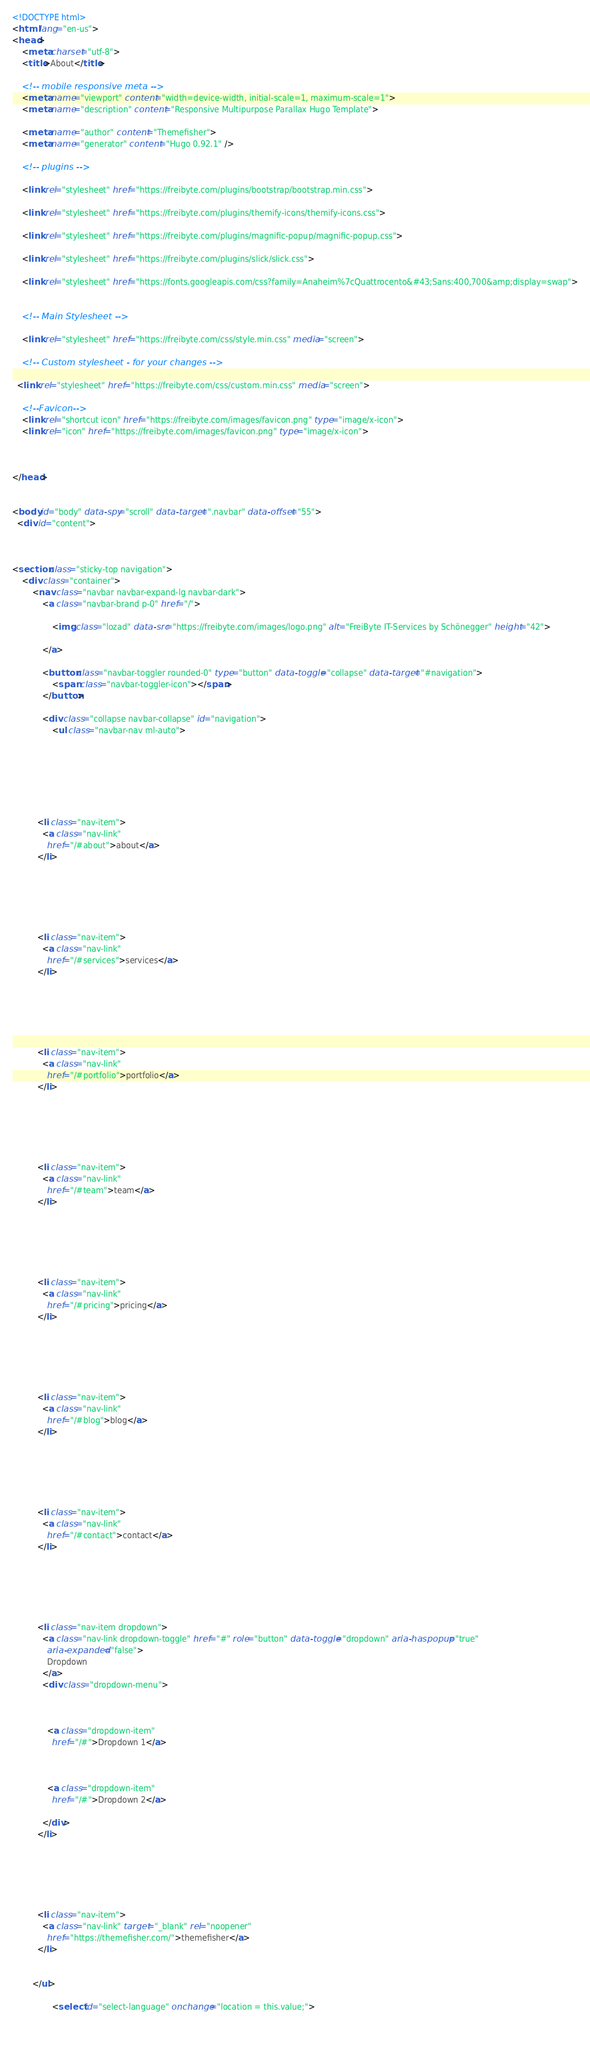Convert code to text. <code><loc_0><loc_0><loc_500><loc_500><_HTML_><!DOCTYPE html>
<html lang="en-us">
<head>
	<meta charset="utf-8">
	<title>About</title>

	<!-- mobile responsive meta -->
	<meta name="viewport" content="width=device-width, initial-scale=1, maximum-scale=1">
	<meta name="description" content="Responsive Multipurpose Parallax Hugo Template">
	
	<meta name="author" content="Themefisher">
	<meta name="generator" content="Hugo 0.92.1" />

	<!-- plugins -->
	
	<link rel="stylesheet" href="https://freibyte.com/plugins/bootstrap/bootstrap.min.css">
	
	<link rel="stylesheet" href="https://freibyte.com/plugins/themify-icons/themify-icons.css">
	
	<link rel="stylesheet" href="https://freibyte.com/plugins/magnific-popup/magnific-popup.css">
	
	<link rel="stylesheet" href="https://freibyte.com/plugins/slick/slick.css">
	
	<link rel="stylesheet" href="https://fonts.googleapis.com/css?family=Anaheim%7cQuattrocento&#43;Sans:400,700&amp;display=swap">
	

	<!-- Main Stylesheet -->
	
	<link rel="stylesheet" href="https://freibyte.com/css/style.min.css" media="screen">

	<!-- Custom stylesheet - for your changes -->
	
  <link rel="stylesheet" href="https://freibyte.com/css/custom.min.css" media="screen">

	<!--Favicon-->
	<link rel="shortcut icon" href="https://freibyte.com/images/favicon.png" type="image/x-icon">
	<link rel="icon" href="https://freibyte.com/images/favicon.png" type="image/x-icon">

	

</head>


<body id="body" data-spy="scroll" data-target=".navbar" data-offset="55">
  <div id="content">
    


<section class="sticky-top navigation">
	<div class="container">
		<nav class="navbar navbar-expand-lg navbar-dark">
			<a class="navbar-brand p-0" href="/">
				
				<img class="lozad" data-src="https://freibyte.com/images/logo.png" alt="FreiByte IT-Services by Schönegger" height="42">
				
			</a>

			<button class="navbar-toggler rounded-0" type="button" data-toggle="collapse" data-target="#navigation">
				<span class="navbar-toggler-icon"></span>
			</button>

			<div class="collapse navbar-collapse" id="navigation">
				<ul class="navbar-nav ml-auto">
          
          
          
          
          
          
          
          <li class="nav-item">
            <a class="nav-link" 
              href="/#about">about</a>
          </li>
          
          
          
          
          
          
          <li class="nav-item">
            <a class="nav-link" 
              href="/#services">services</a>
          </li>
          
          
          
          
          
          
          <li class="nav-item">
            <a class="nav-link" 
              href="/#portfolio">portfolio</a>
          </li>
          
          
          
          
          
          
          <li class="nav-item">
            <a class="nav-link" 
              href="/#team">team</a>
          </li>
          
          
          
          
          
          
          <li class="nav-item">
            <a class="nav-link" 
              href="/#pricing">pricing</a>
          </li>
          
          
          
          
          
          
          <li class="nav-item">
            <a class="nav-link" 
              href="/#blog">blog</a>
          </li>
          
          
          
          
          
          
          <li class="nav-item">
            <a class="nav-link" 
              href="/#contact">contact</a>
          </li>
          
          
          
          
          
          
          <li class="nav-item dropdown">
            <a class="nav-link dropdown-toggle" href="#" role="button" data-toggle="dropdown" aria-haspopup="true"
              aria-expanded="false">
              Dropdown
            </a>
            <div class="dropdown-menu">
              
              
              
              <a class="dropdown-item" 
                href="/#">Dropdown 1</a>
              
              
              
              <a class="dropdown-item" 
                href="/#">Dropdown 2</a>
              
            </div>
          </li>
          
          
          
          
          
          
          <li class="nav-item">
            <a class="nav-link" target="_blank" rel="noopener" 
              href="https://themefisher.com/">themefisher</a>
          </li>
          
          
        </ul>
				
				<select id="select-language" onchange="location = this.value;">
					
					</code> 